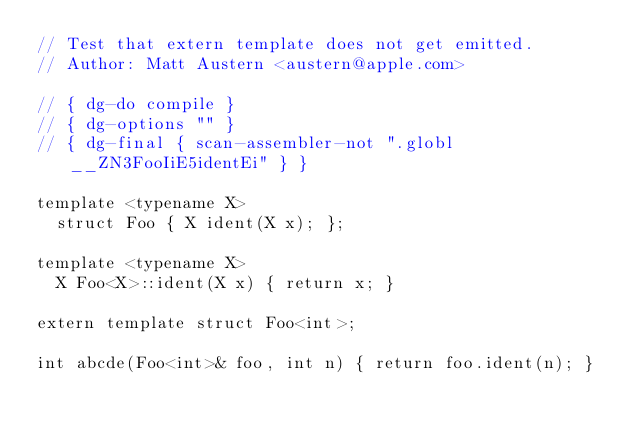Convert code to text. <code><loc_0><loc_0><loc_500><loc_500><_ObjectiveC_>// Test that extern template does not get emitted.
// Author: Matt Austern <austern@apple.com>

// { dg-do compile }
// { dg-options "" }
// { dg-final { scan-assembler-not ".globl __ZN3FooIiE5identEi" } }

template <typename X>
  struct Foo { X ident(X x); };

template <typename X> 
  X Foo<X>::ident(X x) { return x; }

extern template struct Foo<int>;

int abcde(Foo<int>& foo, int n) { return foo.ident(n); }
</code> 